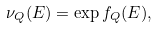Convert formula to latex. <formula><loc_0><loc_0><loc_500><loc_500>\nu _ { Q } ( E ) = \exp f _ { Q } ( E ) ,</formula> 